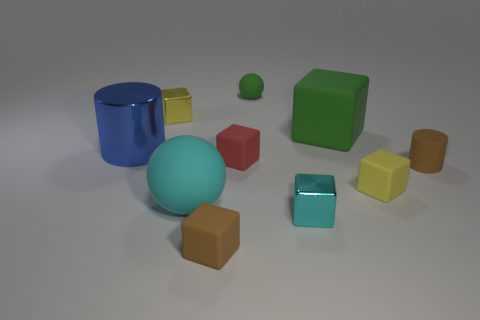There is a sphere in front of the cylinder that is on the right side of the shiny cube that is on the right side of the tiny red matte block; what is its material?
Ensure brevity in your answer.  Rubber. Is the number of tiny brown matte blocks that are on the left side of the tiny rubber ball the same as the number of big blue metal blocks?
Offer a very short reply. No. Is the brown thing on the right side of the tiny cyan metallic object made of the same material as the yellow block that is to the left of the cyan sphere?
Your answer should be very brief. No. Is there anything else that has the same material as the blue object?
Give a very brief answer. Yes. There is a small brown rubber thing that is in front of the brown cylinder; does it have the same shape as the small yellow thing on the right side of the green sphere?
Ensure brevity in your answer.  Yes. Are there fewer small brown rubber blocks that are behind the large blue metal thing than large red metallic cubes?
Offer a very short reply. No. How many cubes have the same color as the large metal cylinder?
Provide a short and direct response. 0. There is a yellow matte object right of the cyan metallic thing; what is its size?
Provide a short and direct response. Small. What shape is the brown matte thing that is to the left of the tiny brown object behind the tiny brown thing that is to the left of the brown matte cylinder?
Your answer should be very brief. Cube. What shape is the small thing that is both to the left of the green ball and in front of the red block?
Your answer should be very brief. Cube. 